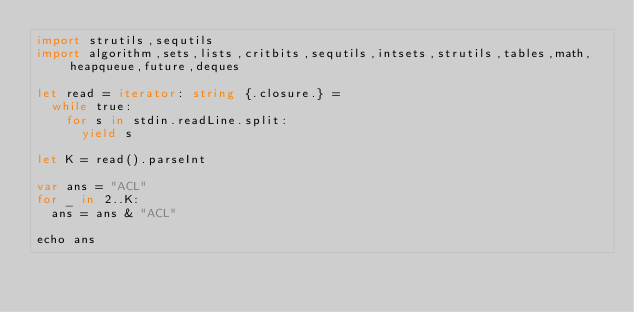Convert code to text. <code><loc_0><loc_0><loc_500><loc_500><_Nim_>import strutils,sequtils
import algorithm,sets,lists,critbits,sequtils,intsets,strutils,tables,math,heapqueue,future,deques

let read = iterator: string {.closure.} =
  while true:
    for s in stdin.readLine.split:
      yield s

let K = read().parseInt

var ans = "ACL"
for _ in 2..K:
  ans = ans & "ACL"

echo ans
</code> 